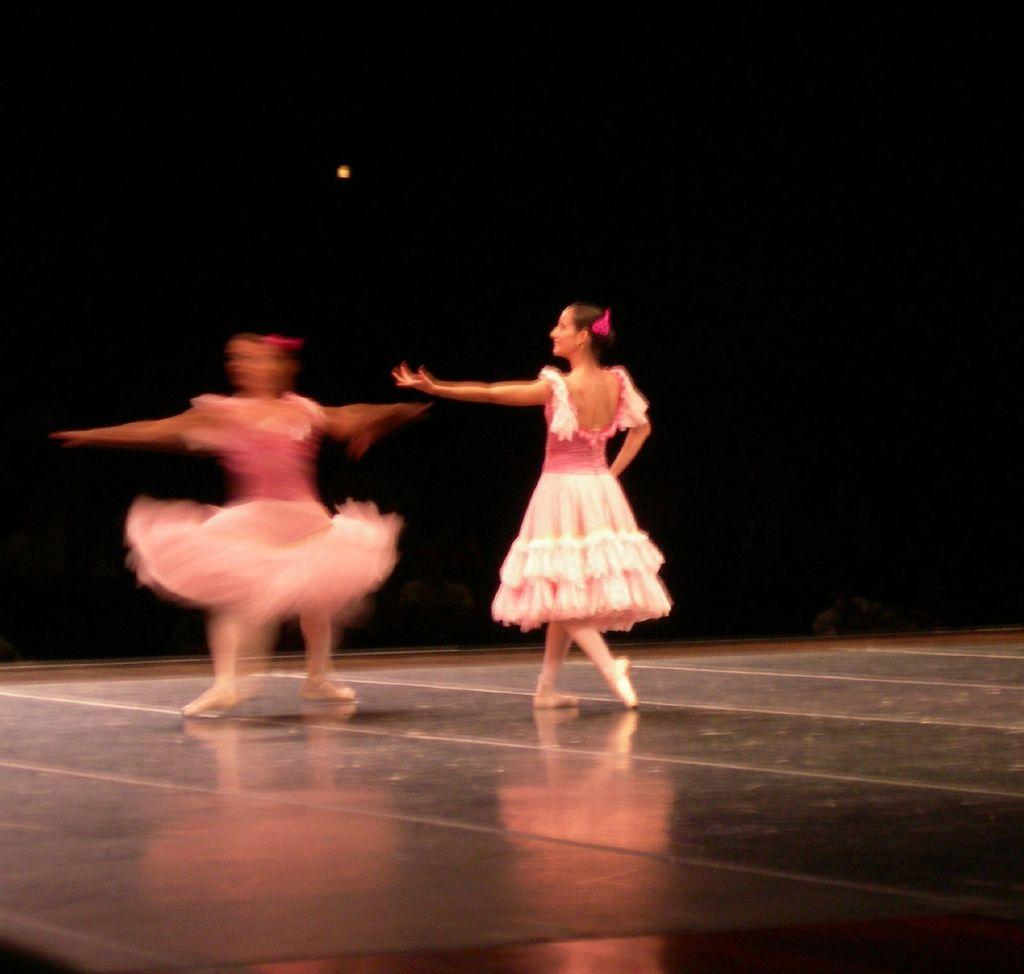How many people are in the image? There are two persons in the image. What are the two persons doing in the image? The two persons are dancing on a stage. What colors are the dresses of the two persons? One person is wearing a pink dress, and the other person is wearing a white dress. What can be observed about the background of the image? The background of the image is dark. Is there any snow visible in the image? No, there is no snow present in the image. What type of support is the stage using in the image? The image does not provide information about the support structure of the stage. 